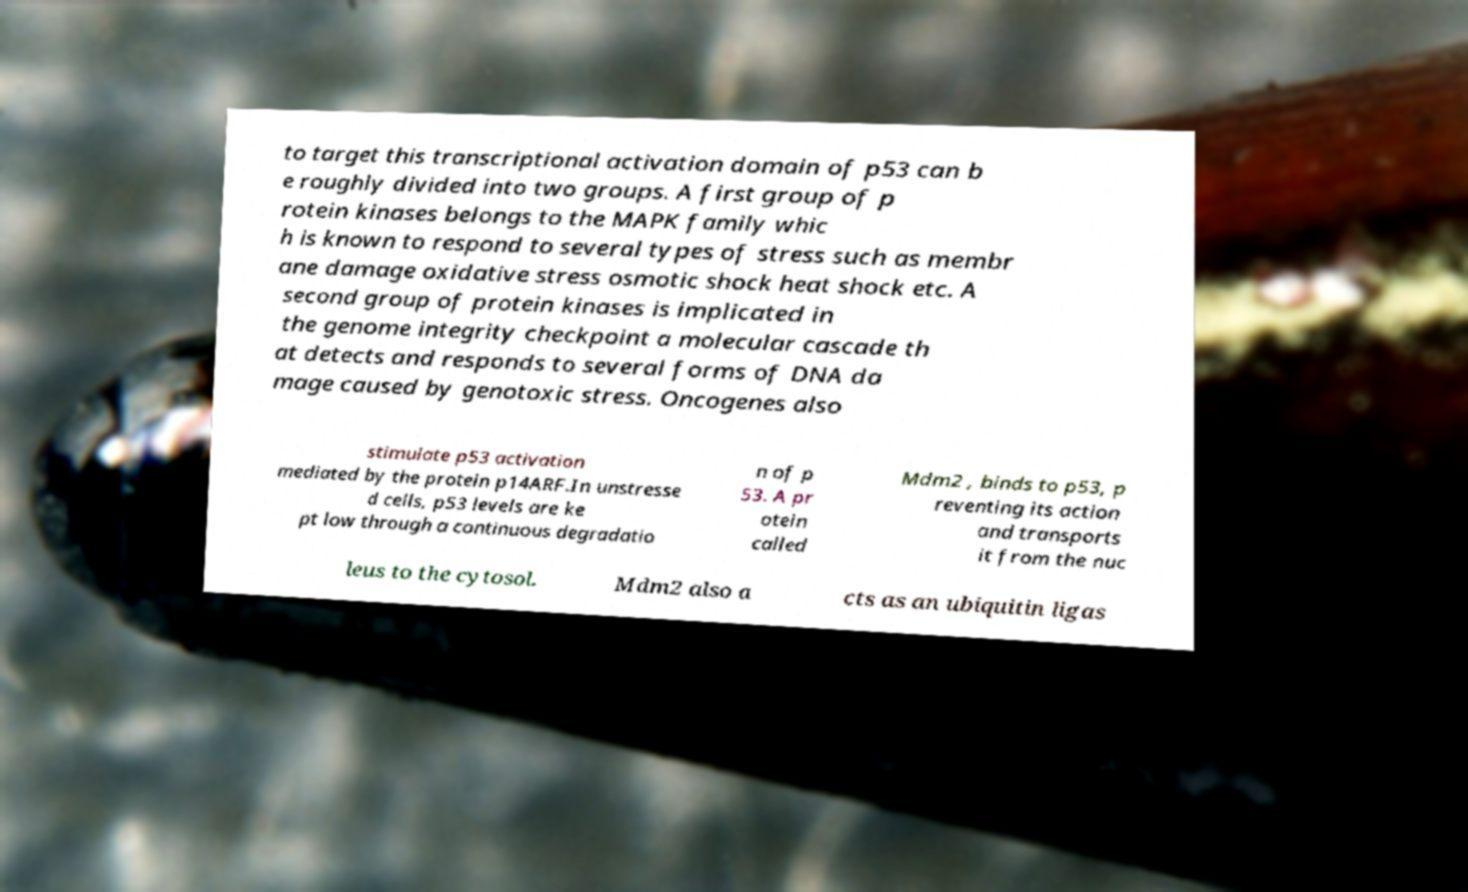Please read and relay the text visible in this image. What does it say? to target this transcriptional activation domain of p53 can b e roughly divided into two groups. A first group of p rotein kinases belongs to the MAPK family whic h is known to respond to several types of stress such as membr ane damage oxidative stress osmotic shock heat shock etc. A second group of protein kinases is implicated in the genome integrity checkpoint a molecular cascade th at detects and responds to several forms of DNA da mage caused by genotoxic stress. Oncogenes also stimulate p53 activation mediated by the protein p14ARF.In unstresse d cells, p53 levels are ke pt low through a continuous degradatio n of p 53. A pr otein called Mdm2 , binds to p53, p reventing its action and transports it from the nuc leus to the cytosol. Mdm2 also a cts as an ubiquitin ligas 